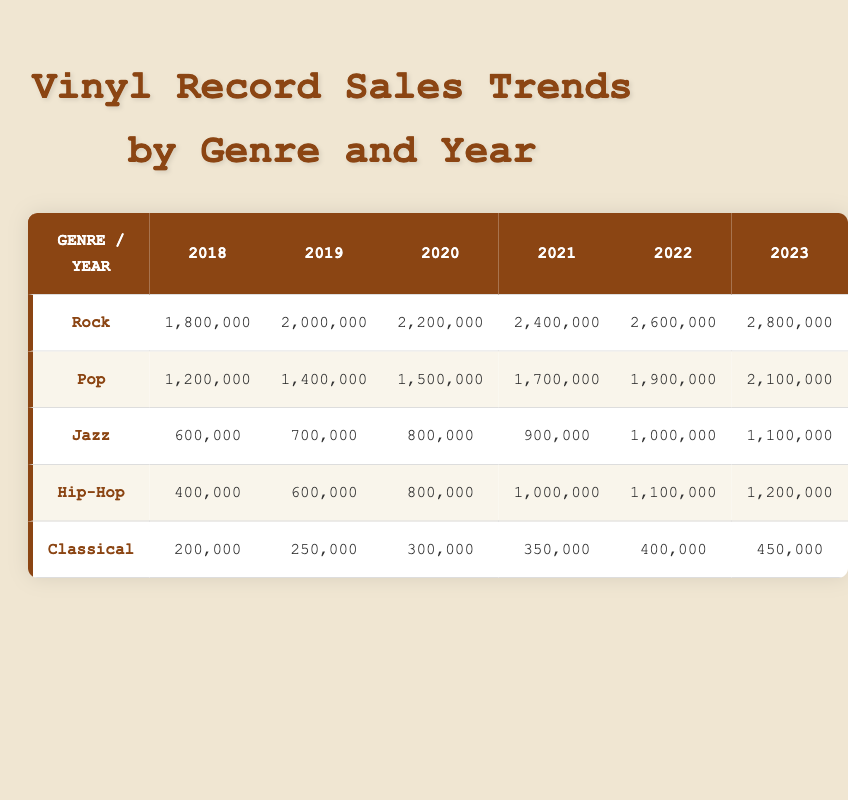What were the total vinyl record sales in the year 2020? In 2020, the total sales can be found by adding the sales across all genres for that year: Rock (2,200,000) + Pop (1,500,000) + Jazz (800,000) + Hip-Hop (800,000) + Classical (300,000) equals 5,600,000.
Answer: 5,600,000 Which genre had the highest sales in 2021? The genre with the highest sales in 2021 is Rock, which had sales of 2,400,000.
Answer: Rock How much did Hip-Hop sales increase from 2018 to 2023? Hip-Hop sales in 2018 were 400,000, and in 2023, they were 1,200,000. The increase is calculated as 1,200,000 - 400,000 = 800,000.
Answer: 800,000 Did Pop sales ever exceed 2 million in any year according to the data? By examining the table, Pop sales reached a maximum of 2,100,000 in 2023. Therefore, Pop sales did exceed 2 million in that year.
Answer: Yes What is the average sales for Jazz over the years provided? To find the average, add the sales figures for Jazz over the years (600,000 + 700,000 + 800,000 + 900,000 + 1,000,000 + 1,100,000 = 5,100,000), then divide by the number of years (6). The average sale for Jazz is 5,100,000 / 6 = 850,000.
Answer: 850,000 Which genre had the smallest sales in 2019, and how many records were sold? In 2019, the smallest sales were in Classical with 250,000 records sold.
Answer: Classical, 250,000 What was the percentage increase in Rock sales from 2018 to 2022? Rock sales in 2018 were 1,800,000, and in 2022 they were 2,600,000. The increase is 2,600,000 - 1,800,000 = 800,000. The percentage increase is calculated as (800,000 / 1,800,000) * 100 which equals approximately 44.44%.
Answer: 44.44% In which year did Jazz sales first reach 900,000? According to the table, Jazz sales first reached 900,000 in 2021.
Answer: 2021 How do Hip-Hop sales in 2020 compare to Classical sales in 2023? Hip-Hop sales in 2020 were 800,000, while Classical sales in 2023 were 450,000. Therefore, Hip-Hop sales in 2020 were higher than Classical sales in 2023.
Answer: Higher 